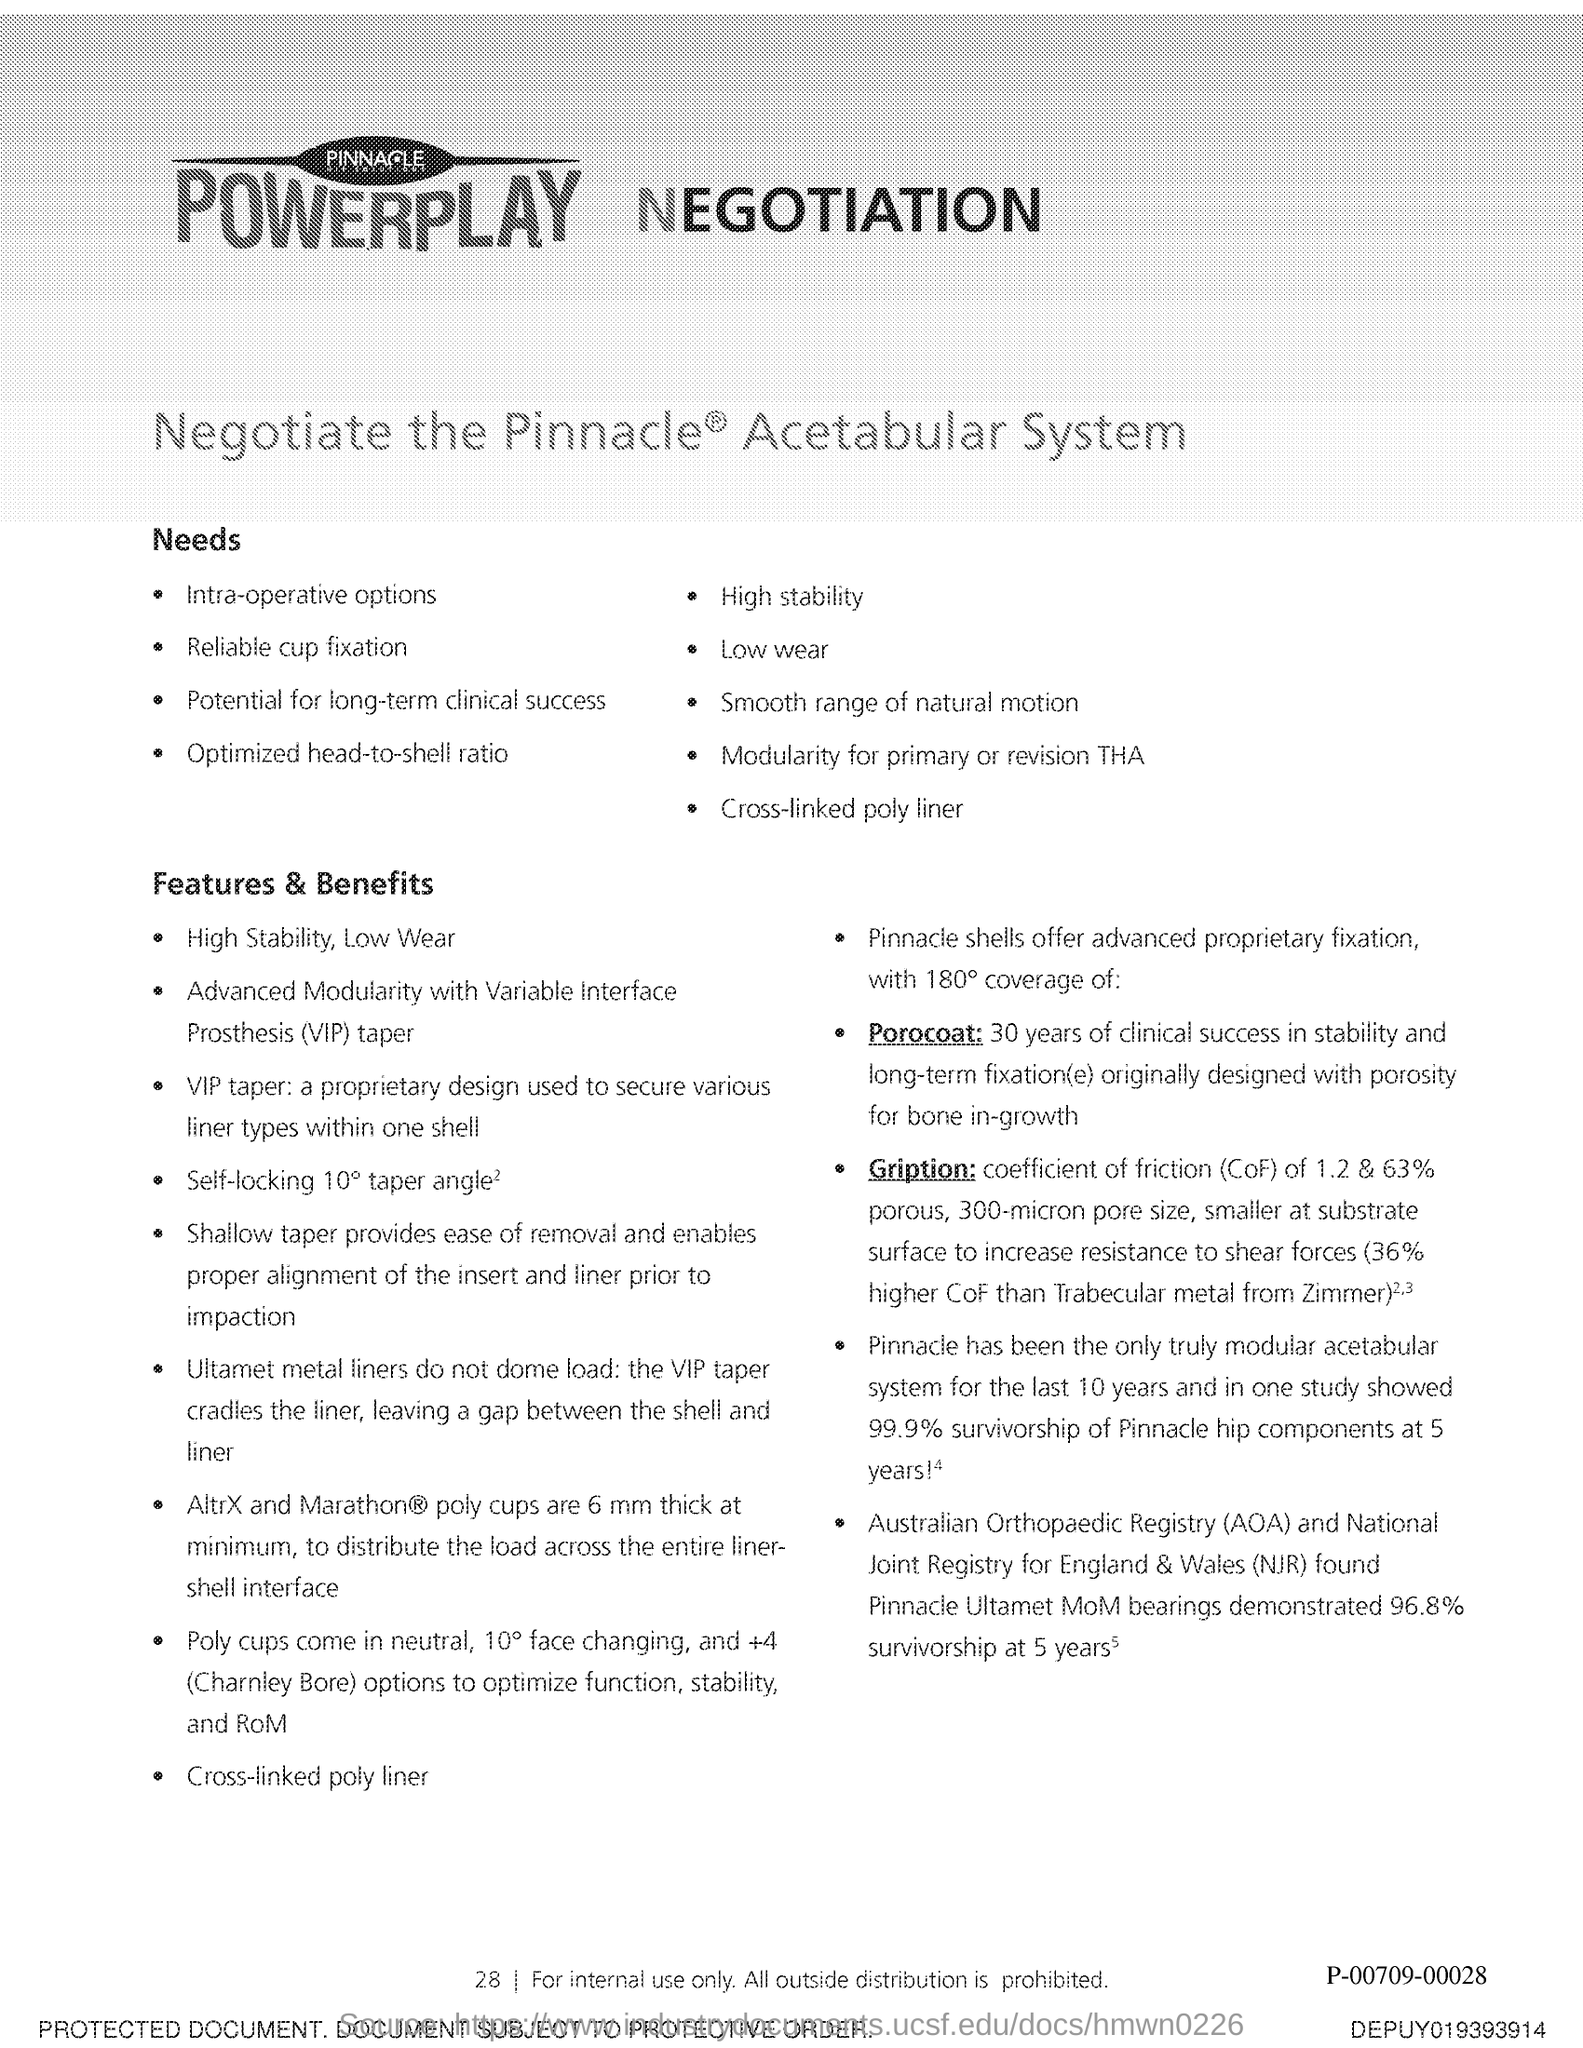What is the Page Number?
Your response must be concise. 28. 